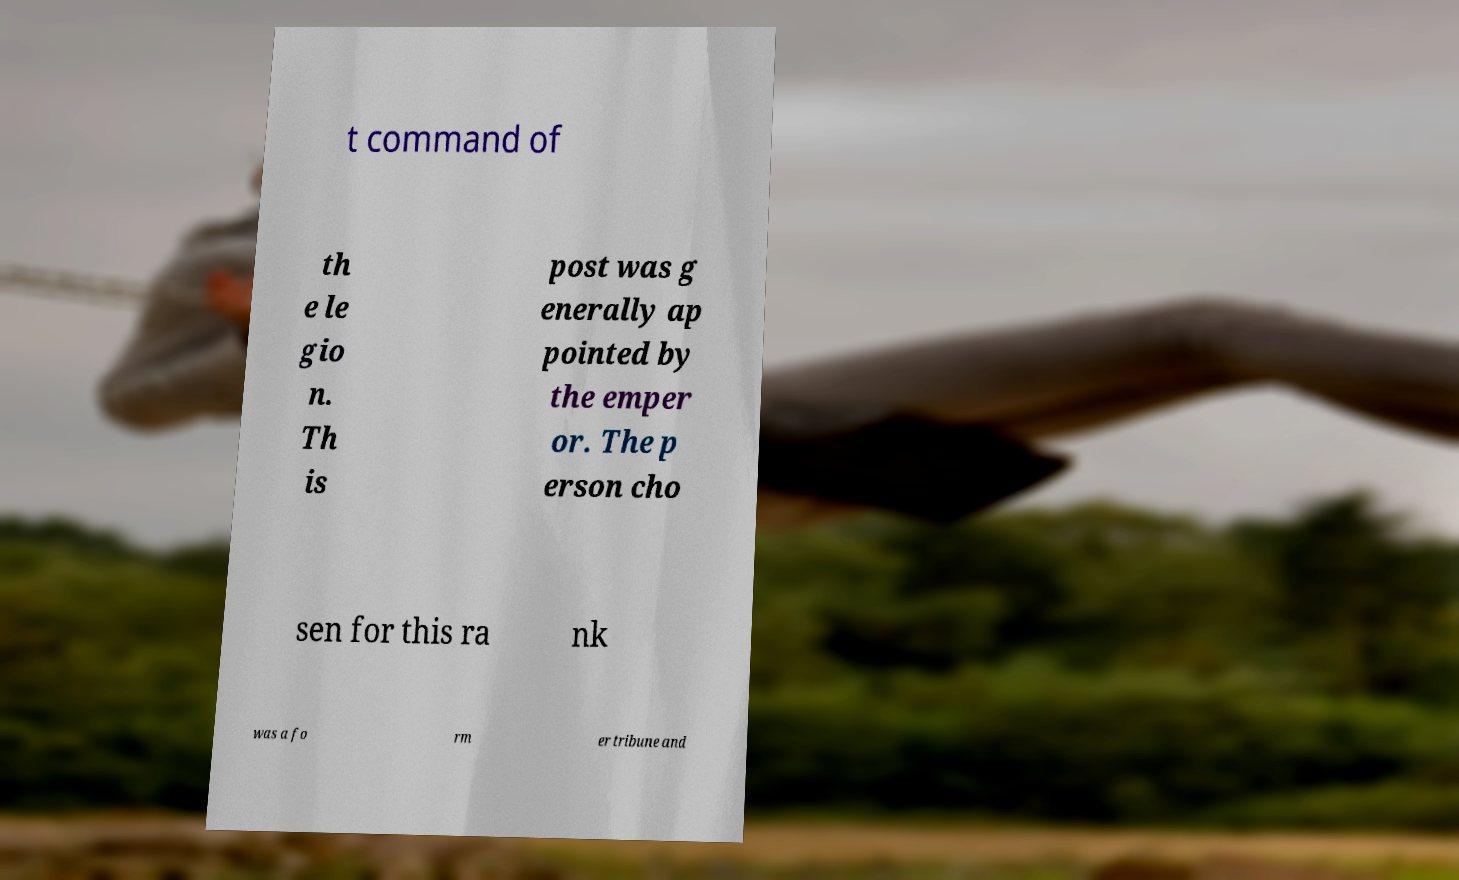There's text embedded in this image that I need extracted. Can you transcribe it verbatim? t command of th e le gio n. Th is post was g enerally ap pointed by the emper or. The p erson cho sen for this ra nk was a fo rm er tribune and 